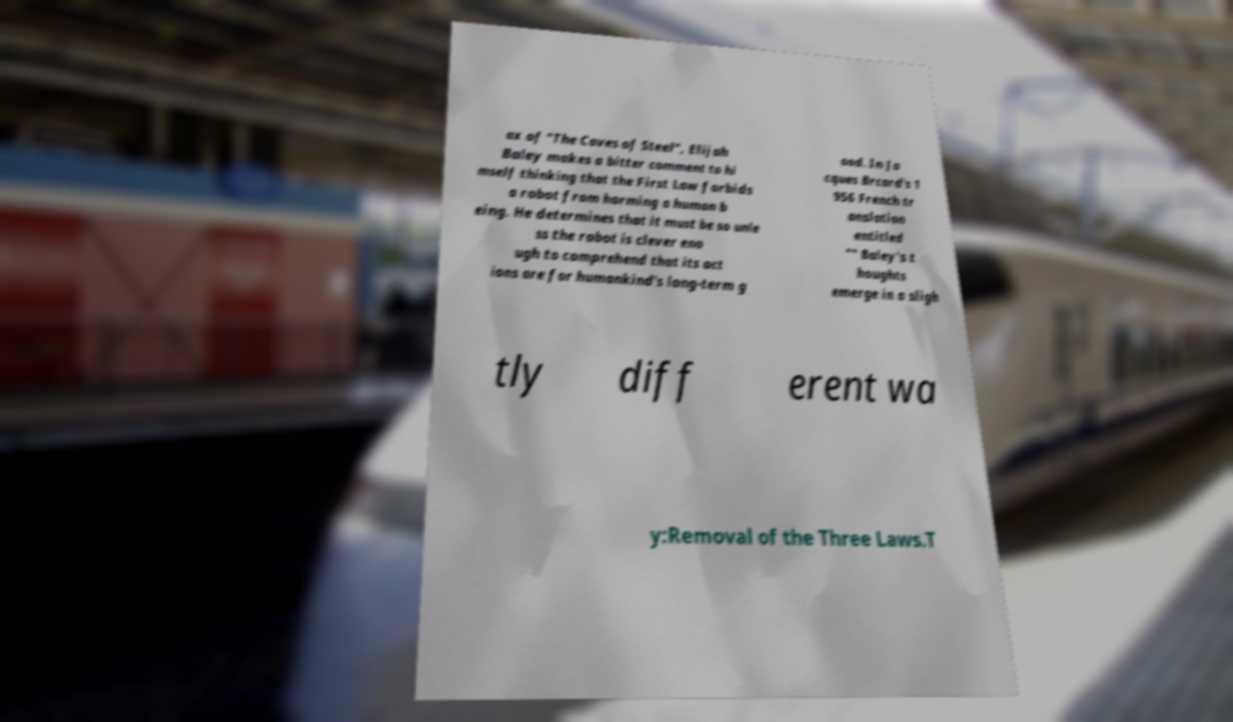Please identify and transcribe the text found in this image. ax of "The Caves of Steel", Elijah Baley makes a bitter comment to hi mself thinking that the First Law forbids a robot from harming a human b eing. He determines that it must be so unle ss the robot is clever eno ugh to comprehend that its act ions are for humankind's long-term g ood. In Ja cques Brcard's 1 956 French tr anslation entitled "" Baley's t houghts emerge in a sligh tly diff erent wa y:Removal of the Three Laws.T 